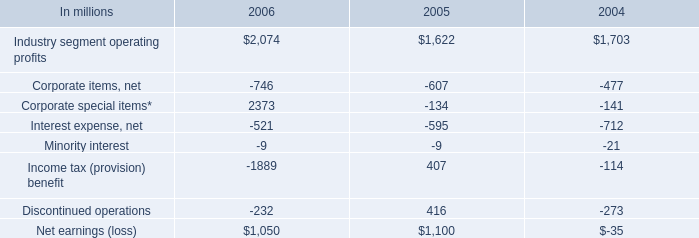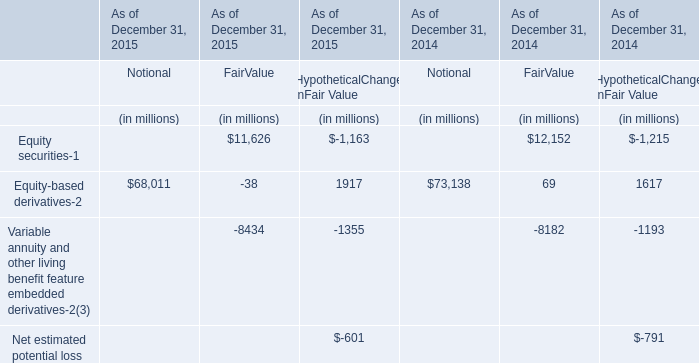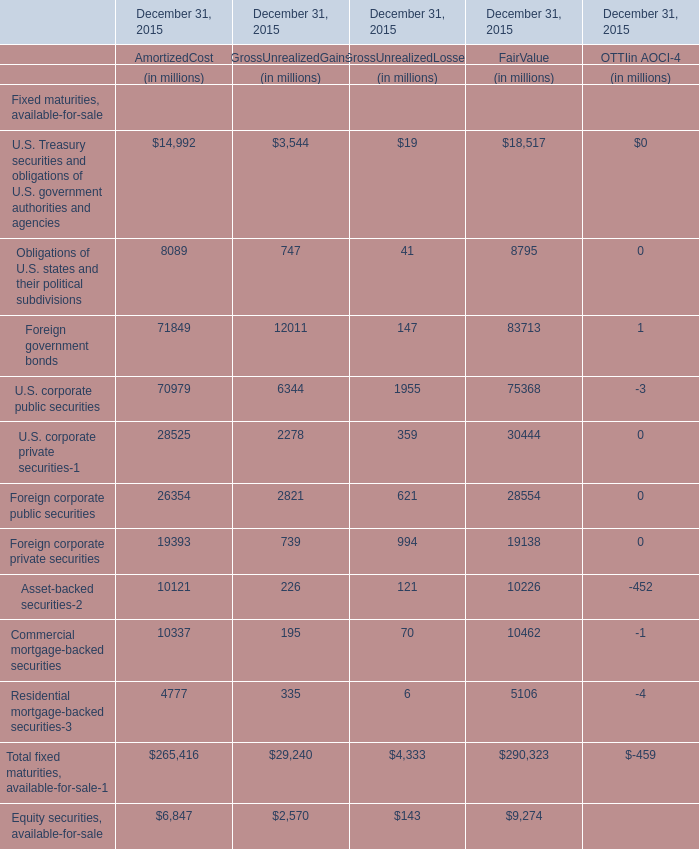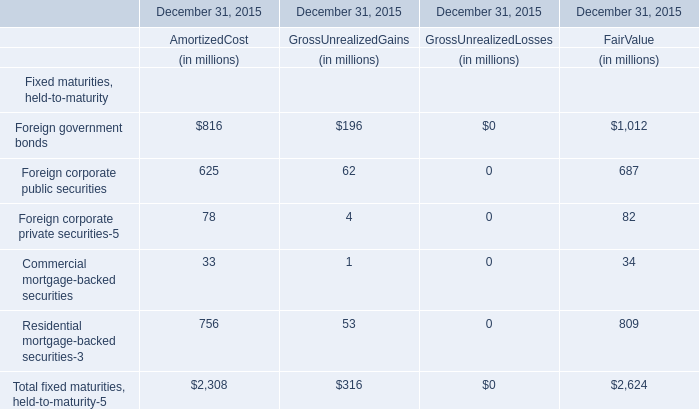How many elements show negative value in 2015 for AmortizedCost? 
Answer: 0. 